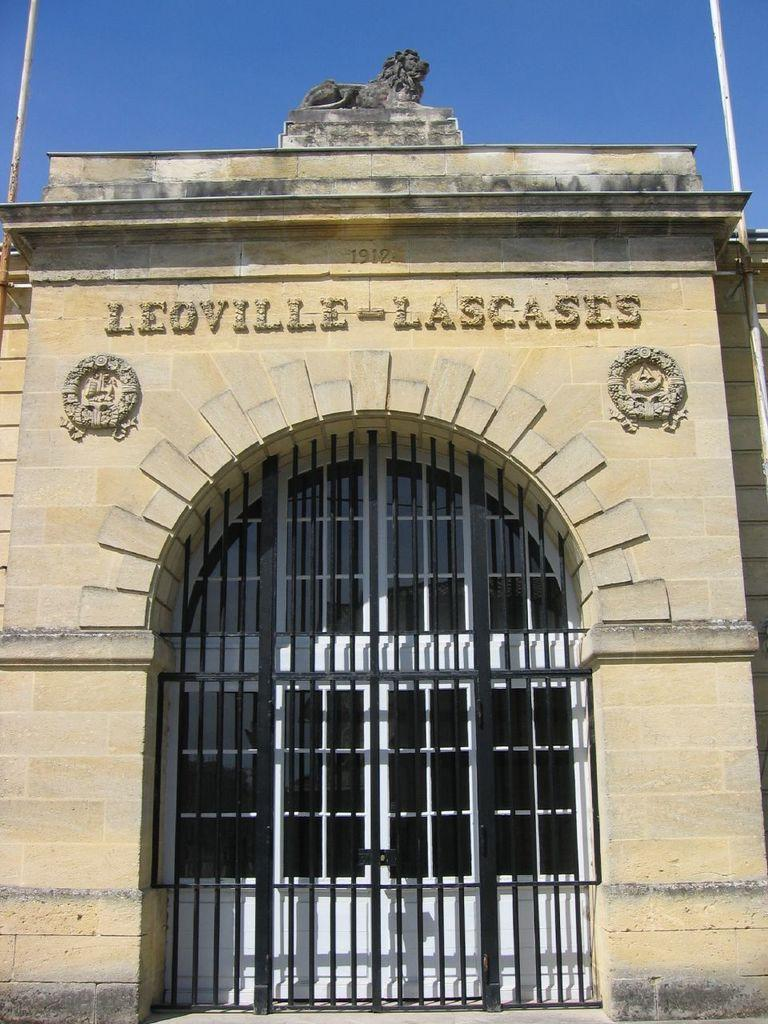What type of structure is present in the image? There is a building in the image. What is the entrance to the building like? There is a gate in the image. What can be seen in the background of the image? The sky is visible in the background of the image. How many appliances can be seen inside the building in the image? There is no information about appliances inside the building in the image. Are there any pets visible in the image? There is no mention of pets in the image. 